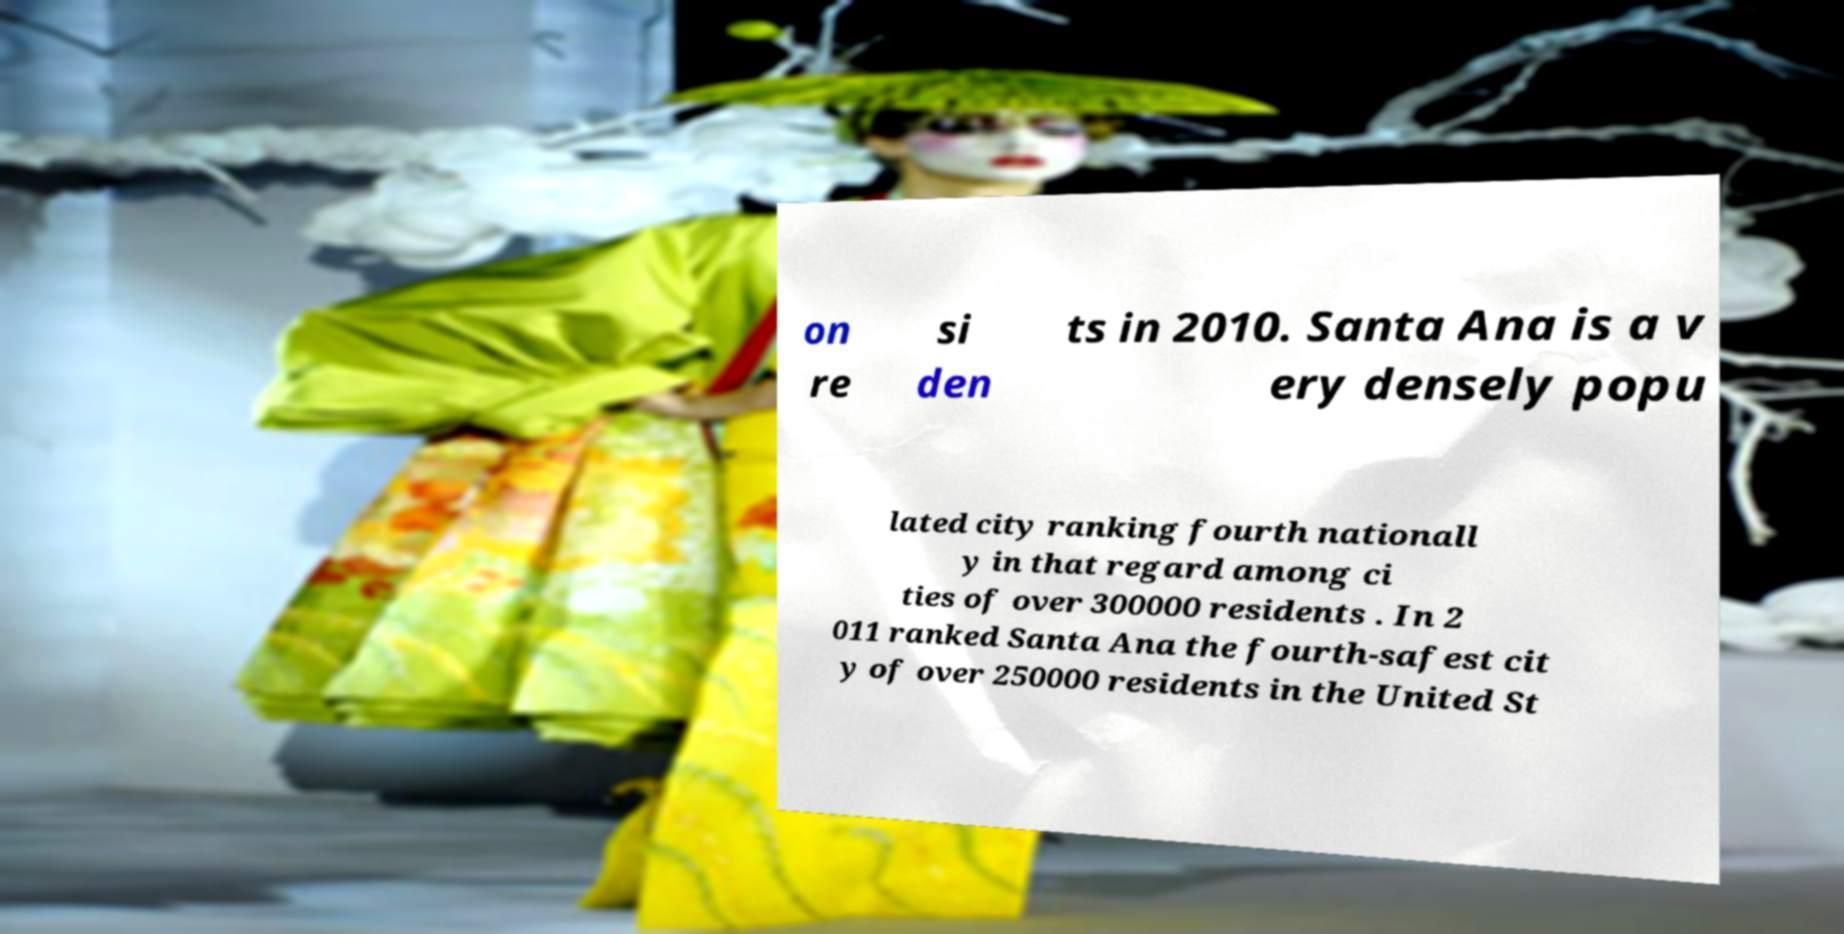I need the written content from this picture converted into text. Can you do that? on re si den ts in 2010. Santa Ana is a v ery densely popu lated city ranking fourth nationall y in that regard among ci ties of over 300000 residents . In 2 011 ranked Santa Ana the fourth-safest cit y of over 250000 residents in the United St 